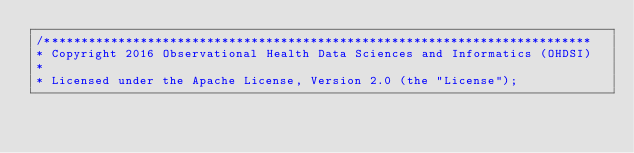<code> <loc_0><loc_0><loc_500><loc_500><_SQL_>/**************************************************************************
* Copyright 2016 Observational Health Data Sciences and Informatics (OHDSI)
*
* Licensed under the Apache License, Version 2.0 (the "License");</code> 